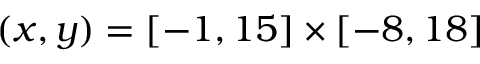<formula> <loc_0><loc_0><loc_500><loc_500>( x , y ) = [ - 1 , 1 5 ] \times [ - 8 , 1 8 ]</formula> 